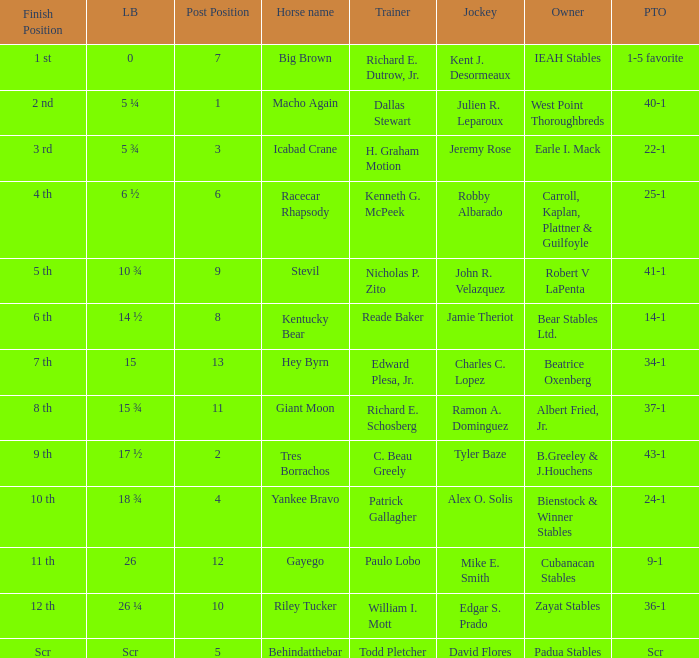What are the measurements related to jockey ramon a. dominguez's length? 15 ¾. 